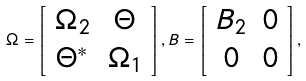Convert formula to latex. <formula><loc_0><loc_0><loc_500><loc_500>\Omega = \left [ \begin{array} [ c ] { c c } \Omega _ { 2 } & \Theta \\ \Theta ^ { \ast } & \Omega _ { 1 } \end{array} \right ] , B = \left [ \begin{array} [ c ] { c c } B _ { 2 } & 0 \\ 0 & 0 \end{array} \right ] ,</formula> 